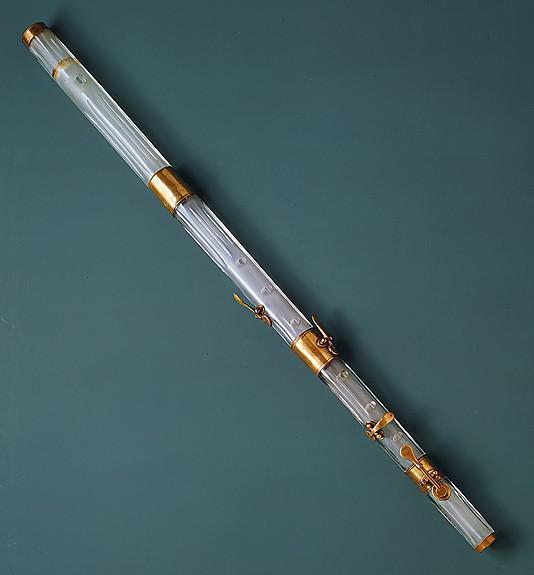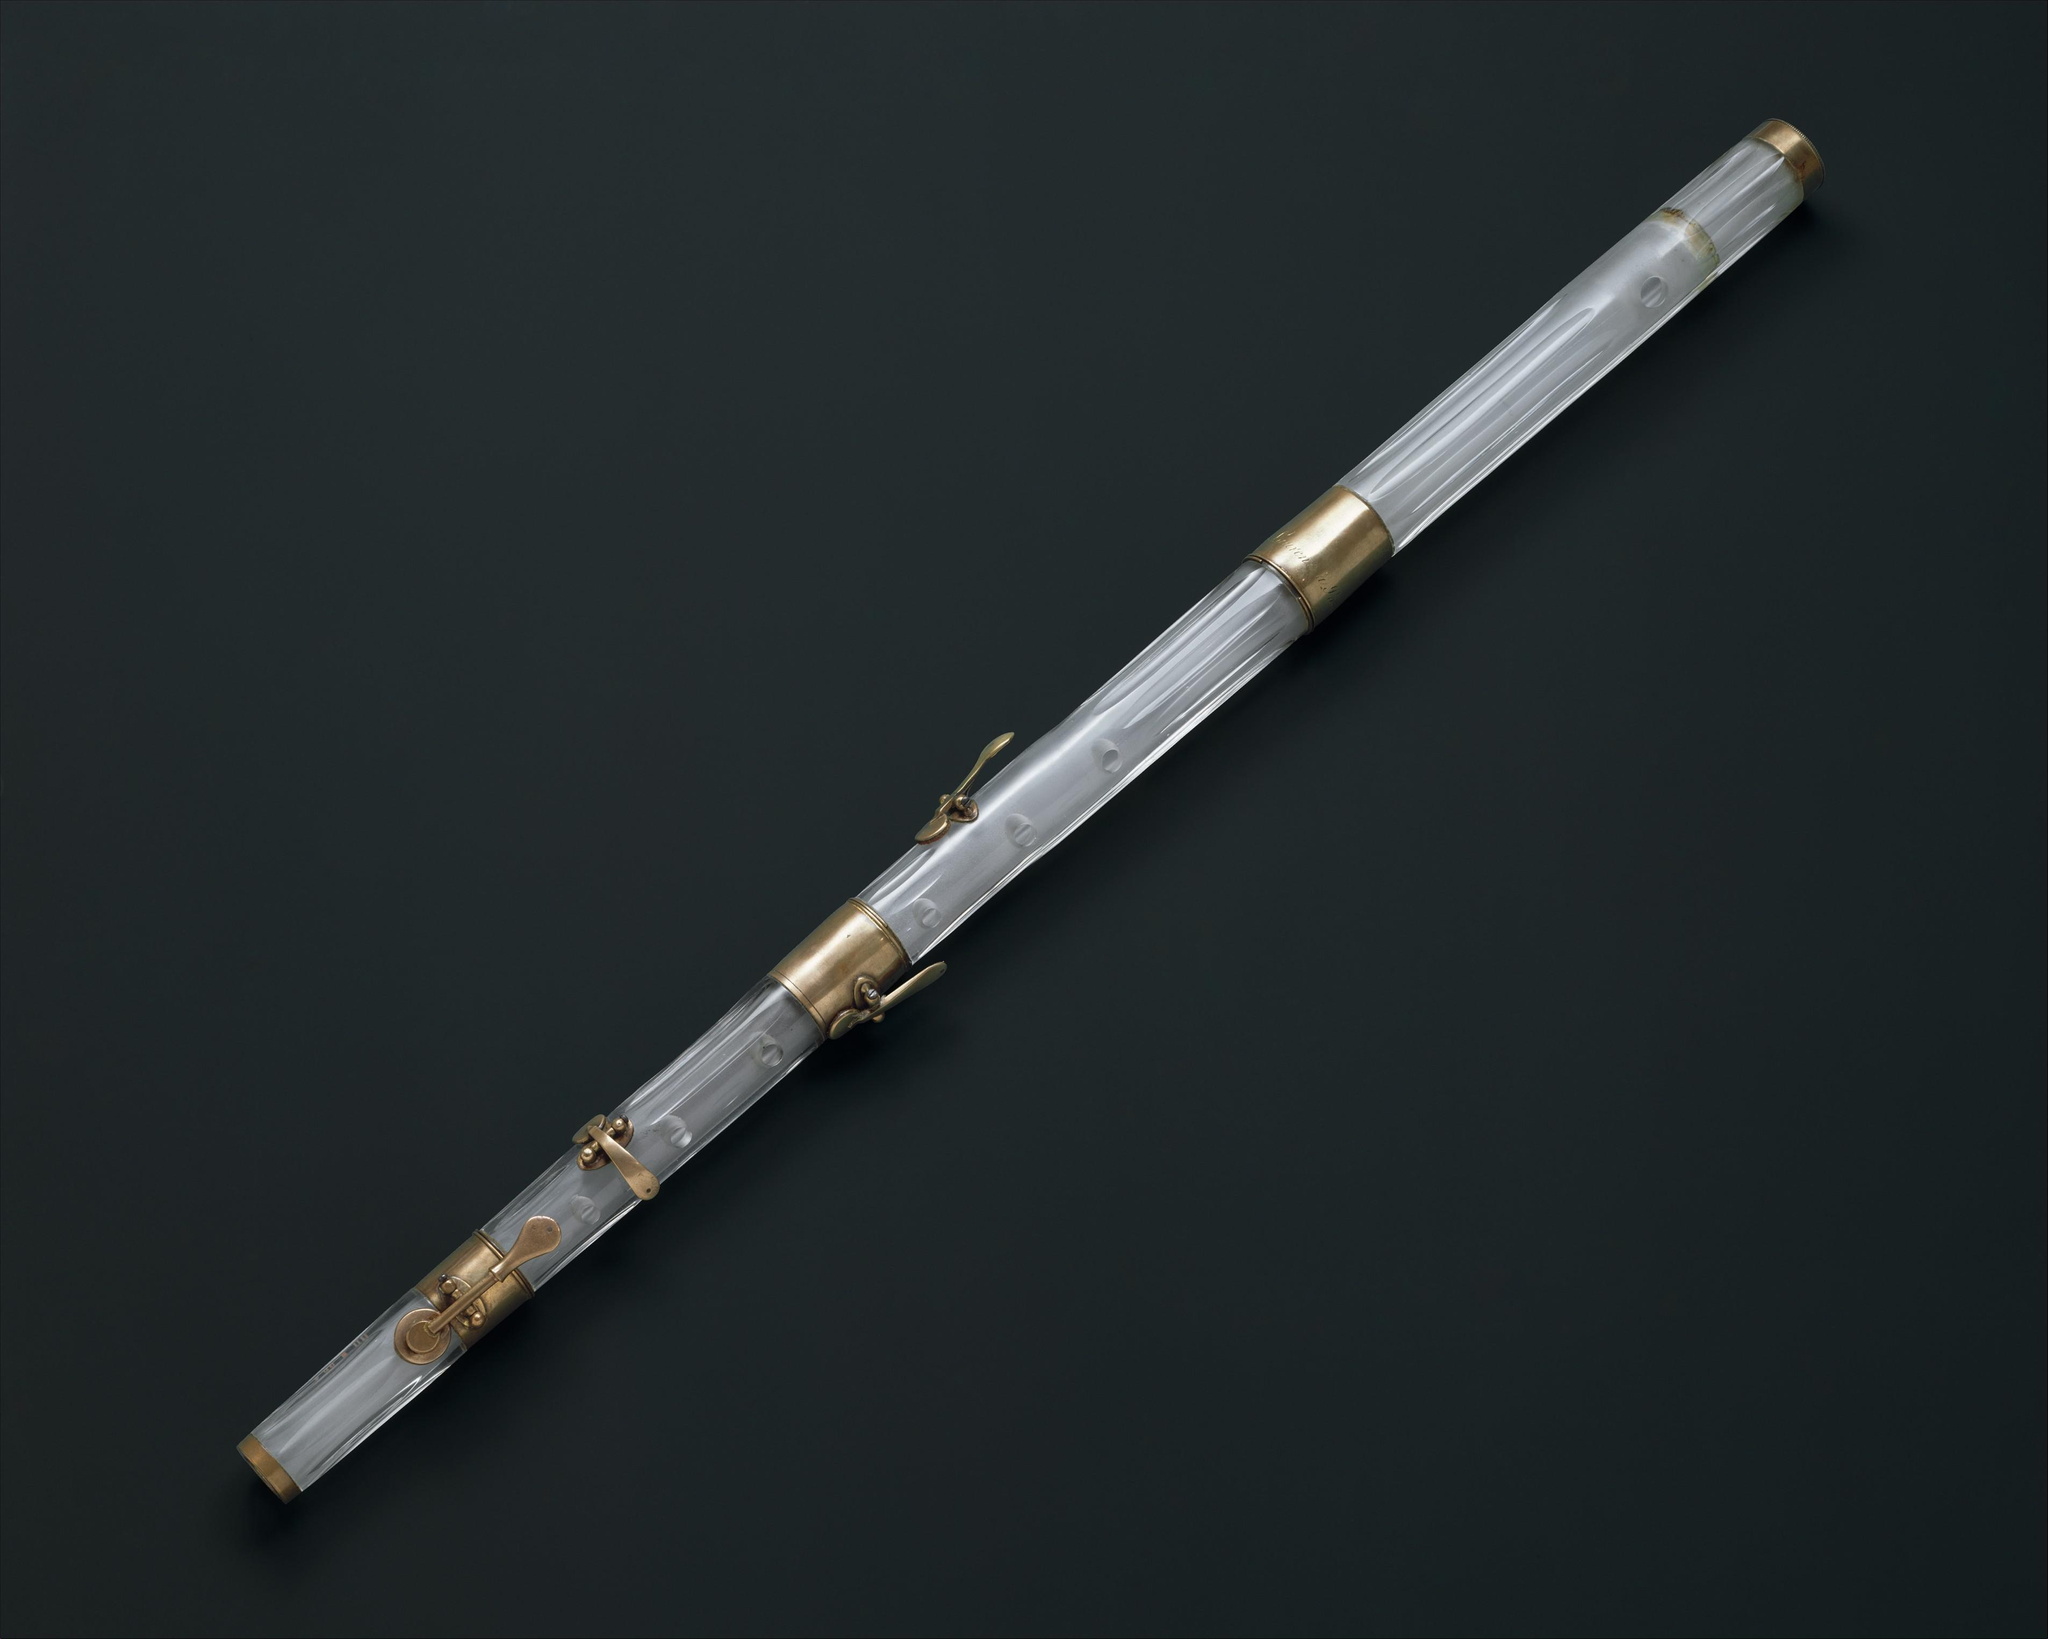The first image is the image on the left, the second image is the image on the right. Evaluate the accuracy of this statement regarding the images: "There are two instruments in the image on the left.". Is it true? Answer yes or no. No. The first image is the image on the left, the second image is the image on the right. Examine the images to the left and right. Is the description "The right image shows a small wind instrument decorated with a wrapped garland and posed with 2 smaller sections and a carved wood carrying case." accurate? Answer yes or no. No. 